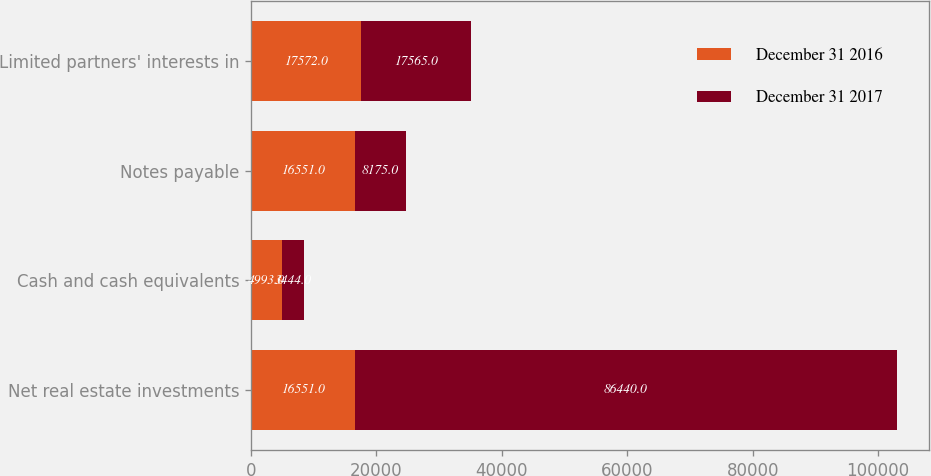Convert chart. <chart><loc_0><loc_0><loc_500><loc_500><stacked_bar_chart><ecel><fcel>Net real estate investments<fcel>Cash and cash equivalents<fcel>Notes payable<fcel>Limited partners' interests in<nl><fcel>December 31 2016<fcel>16551<fcel>4993<fcel>16551<fcel>17572<nl><fcel>December 31 2017<fcel>86440<fcel>3444<fcel>8175<fcel>17565<nl></chart> 